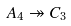<formula> <loc_0><loc_0><loc_500><loc_500>A _ { 4 } \twoheadrightarrow C _ { 3 }</formula> 